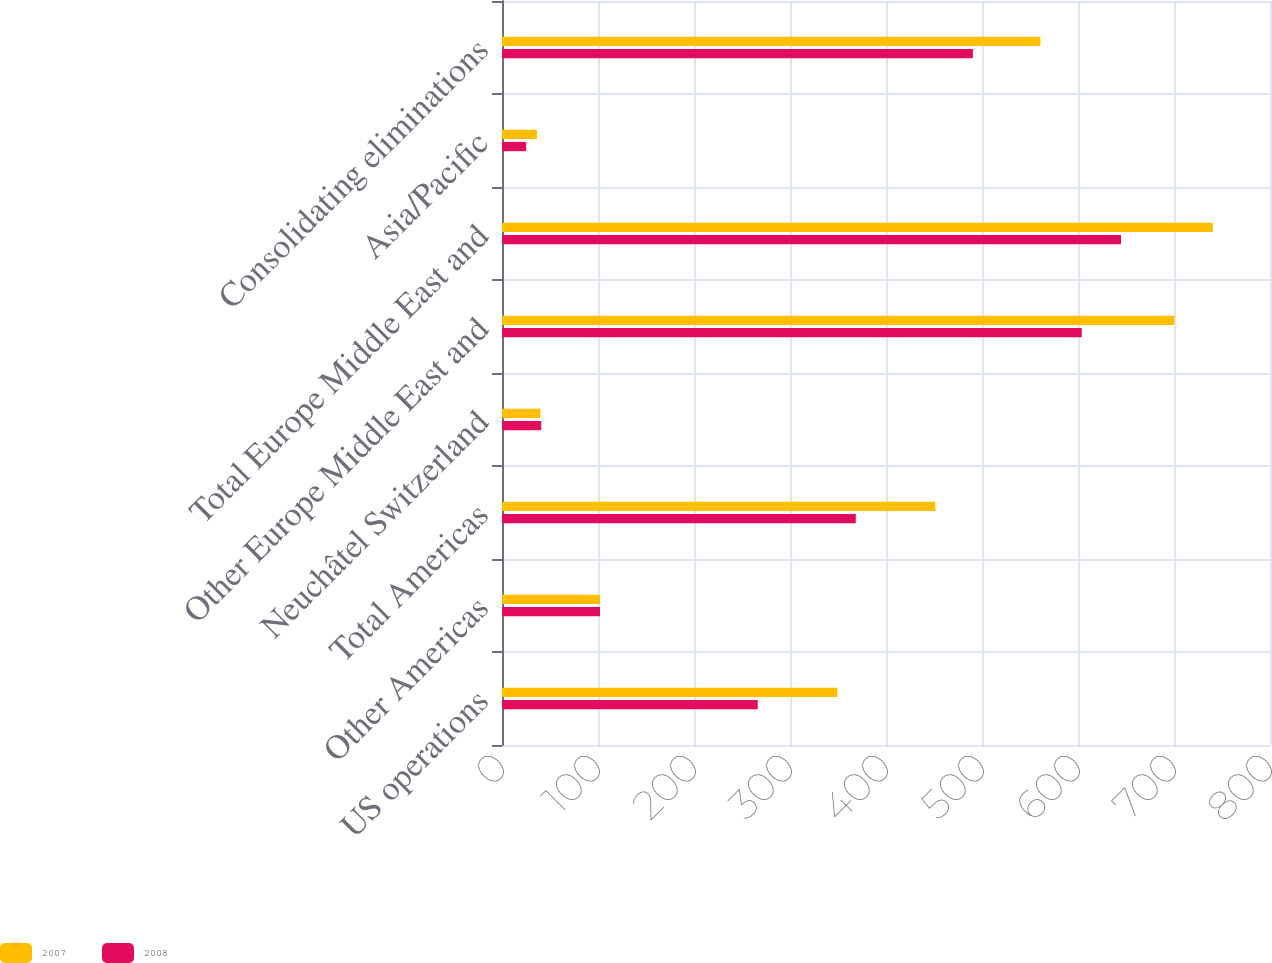<chart> <loc_0><loc_0><loc_500><loc_500><stacked_bar_chart><ecel><fcel>US operations<fcel>Other Americas<fcel>Total Americas<fcel>Neuchâtel Switzerland<fcel>Other Europe Middle East and<fcel>Total Europe Middle East and<fcel>Asia/Pacific<fcel>Consolidating eliminations<nl><fcel>2007<fcel>349.3<fcel>102.1<fcel>451.4<fcel>40<fcel>700.5<fcel>740.5<fcel>36.4<fcel>560.9<nl><fcel>2008<fcel>266.4<fcel>102.1<fcel>368.5<fcel>40.9<fcel>603.9<fcel>644.8<fcel>25.2<fcel>490.5<nl></chart> 